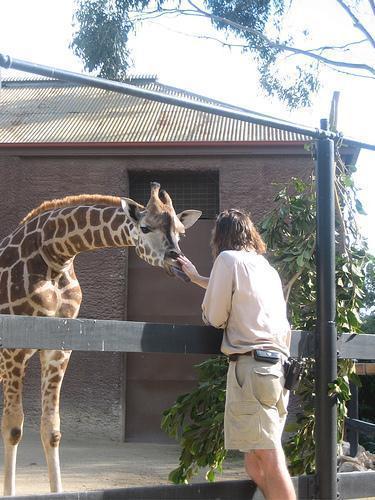How many laptops are on the table?
Give a very brief answer. 0. 